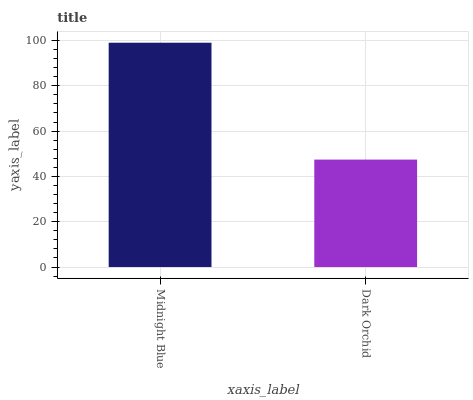Is Dark Orchid the minimum?
Answer yes or no. Yes. Is Midnight Blue the maximum?
Answer yes or no. Yes. Is Dark Orchid the maximum?
Answer yes or no. No. Is Midnight Blue greater than Dark Orchid?
Answer yes or no. Yes. Is Dark Orchid less than Midnight Blue?
Answer yes or no. Yes. Is Dark Orchid greater than Midnight Blue?
Answer yes or no. No. Is Midnight Blue less than Dark Orchid?
Answer yes or no. No. Is Midnight Blue the high median?
Answer yes or no. Yes. Is Dark Orchid the low median?
Answer yes or no. Yes. Is Dark Orchid the high median?
Answer yes or no. No. Is Midnight Blue the low median?
Answer yes or no. No. 